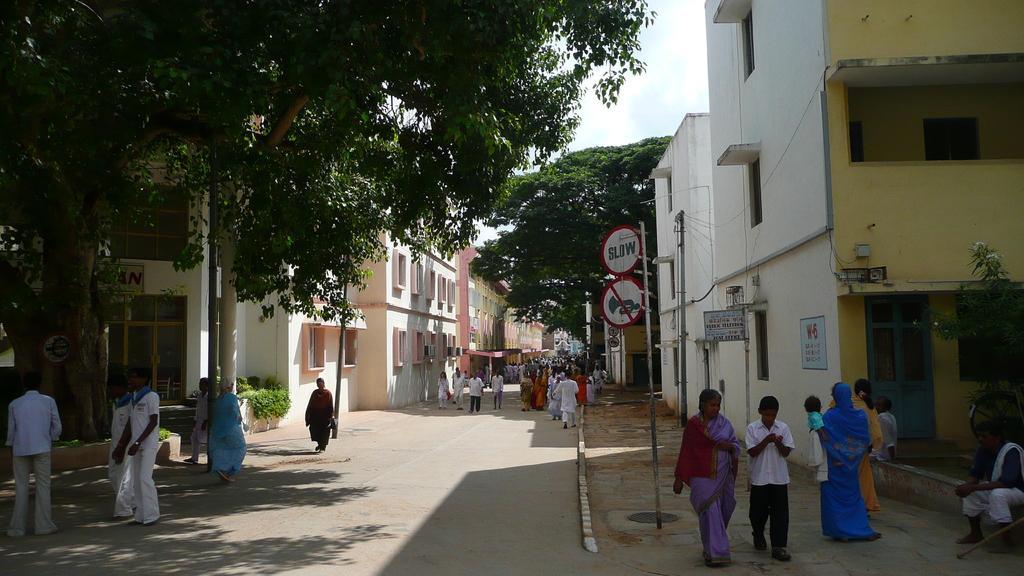Can you describe this image briefly? In this image, we can see people on the road and in the background, there are trees, buildings, poles along with wires and there are boards and some plants. At the top, there is sky. 